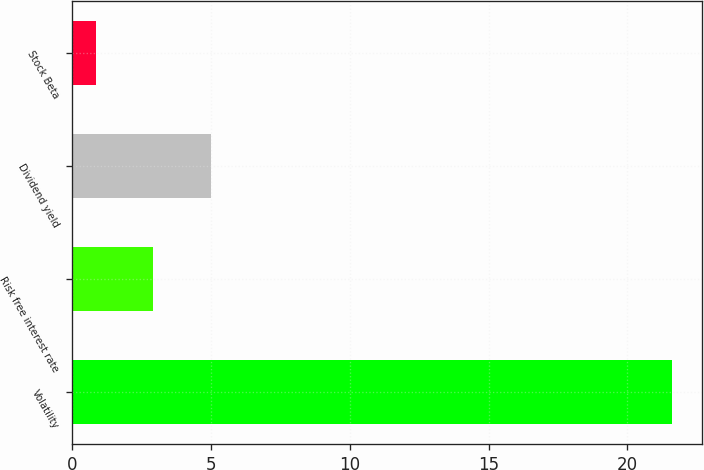Convert chart. <chart><loc_0><loc_0><loc_500><loc_500><bar_chart><fcel>Volatility<fcel>Risk free interest rate<fcel>Dividend yield<fcel>Stock Beta<nl><fcel>21.6<fcel>2.92<fcel>5<fcel>0.84<nl></chart> 